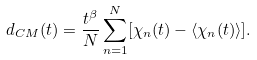Convert formula to latex. <formula><loc_0><loc_0><loc_500><loc_500>d _ { C M } ( t ) = \frac { t ^ { \beta } } { N } \sum _ { n = 1 } ^ { N } [ \chi _ { n } ( t ) - \langle \chi _ { n } ( t ) \rangle ] .</formula> 